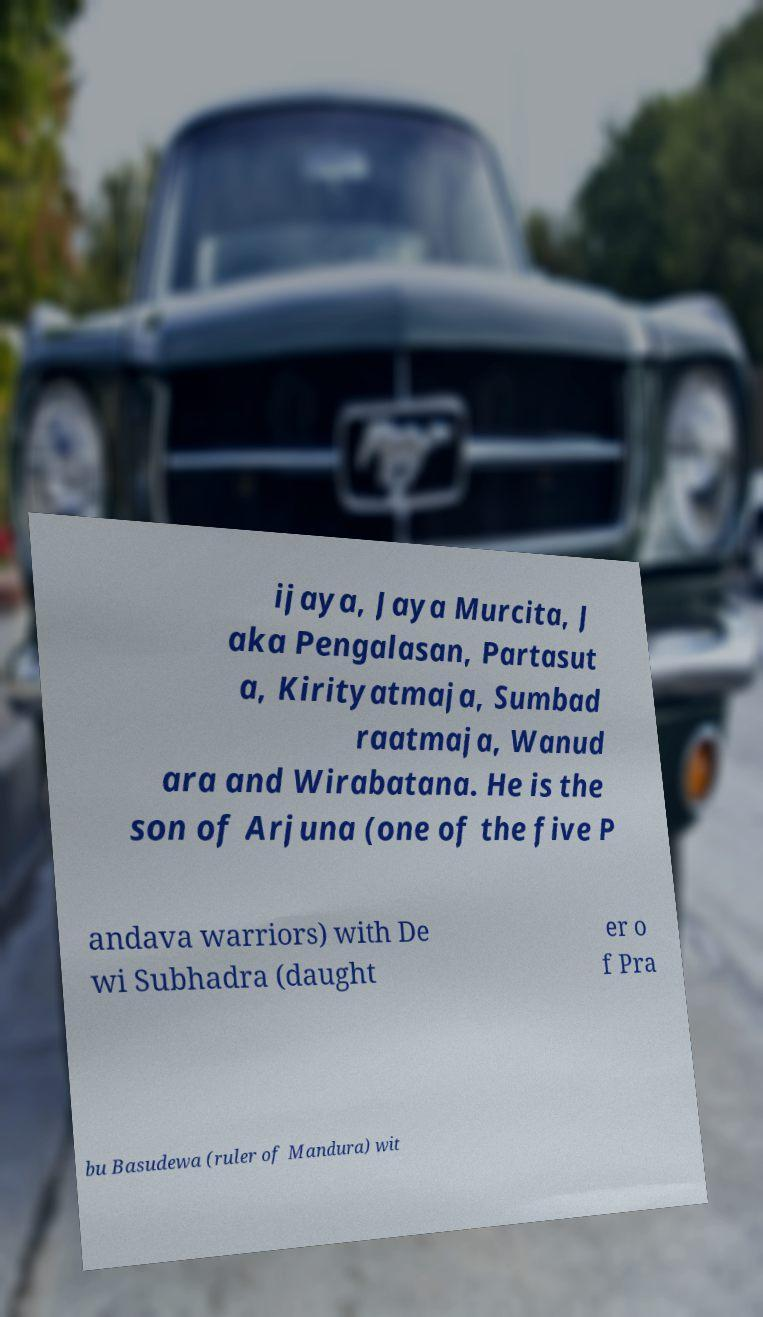Could you extract and type out the text from this image? ijaya, Jaya Murcita, J aka Pengalasan, Partasut a, Kirityatmaja, Sumbad raatmaja, Wanud ara and Wirabatana. He is the son of Arjuna (one of the five P andava warriors) with De wi Subhadra (daught er o f Pra bu Basudewa (ruler of Mandura) wit 